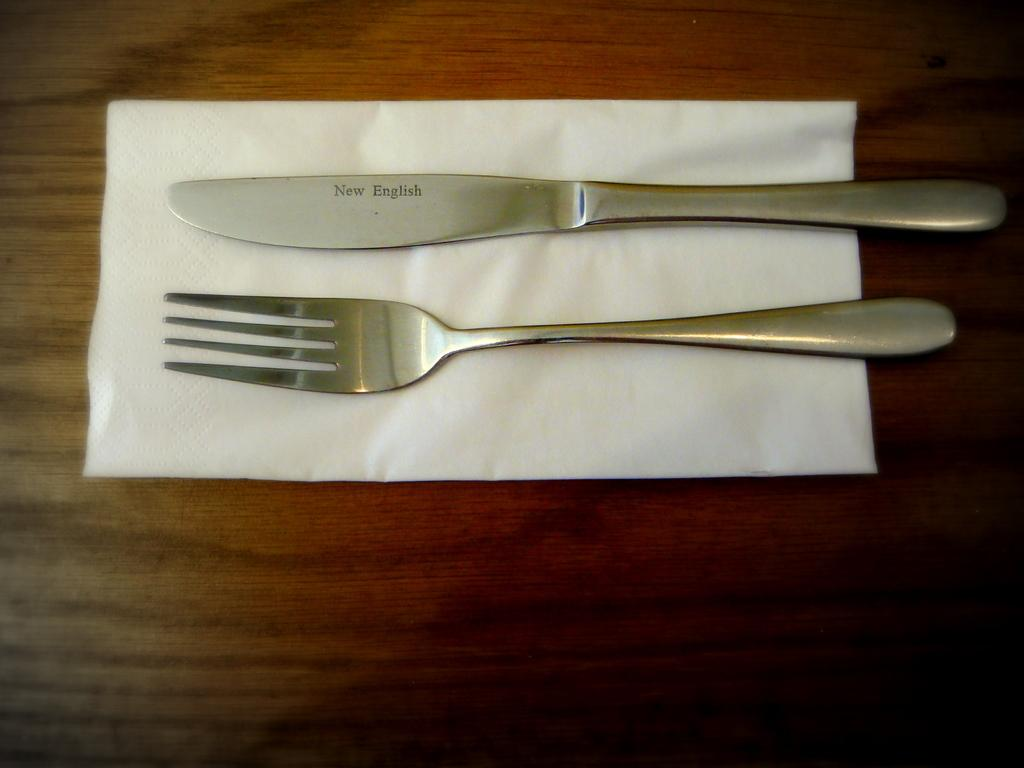What utensils are visible in the image? There is a knife and a fork in the image. Where are the knife and fork located? The knife and fork are on a tissue. What type of class is being taught in the image? There is no class or teaching activity depicted in the image; it only shows a knife and fork on a tissue. 